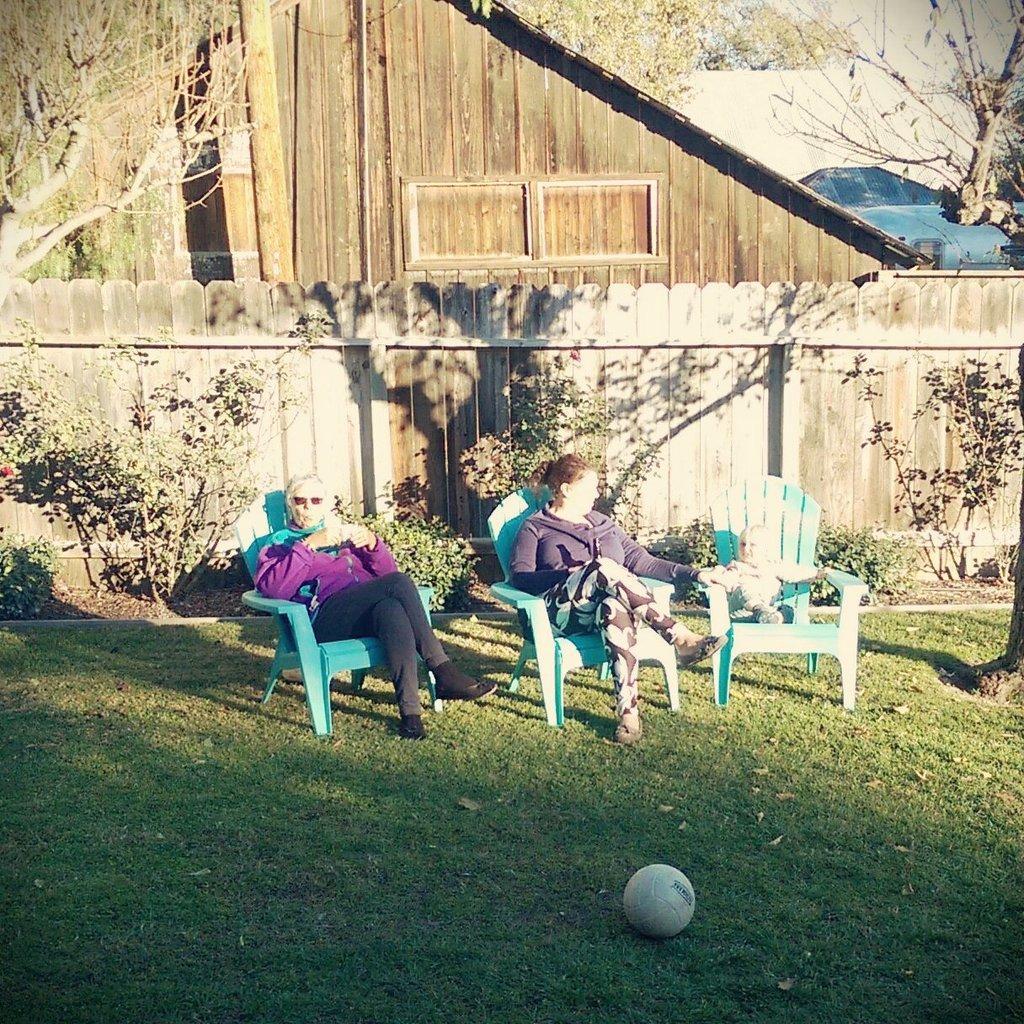Can you describe this image briefly? In this image we can see two women and a baby are sitting on the chairs. At the top of the image, we can see a house and trees. At the bottom of the image, we can see a ball on the grassy land. Behind the woman, we can see plants and wooden boundary. It seems like a vehicle in the right top of the image. 